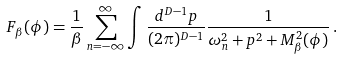<formula> <loc_0><loc_0><loc_500><loc_500>F _ { \beta } ( \phi ) = \frac { 1 } { \beta } \sum _ { n = - \infty } ^ { \infty } \int \frac { d ^ { D - 1 } p } { ( 2 \pi ) ^ { D - 1 } } \frac { 1 } { \omega ^ { 2 } _ { n } + p ^ { 2 } + M ^ { 2 } _ { \beta } ( \phi ) } \, .</formula> 